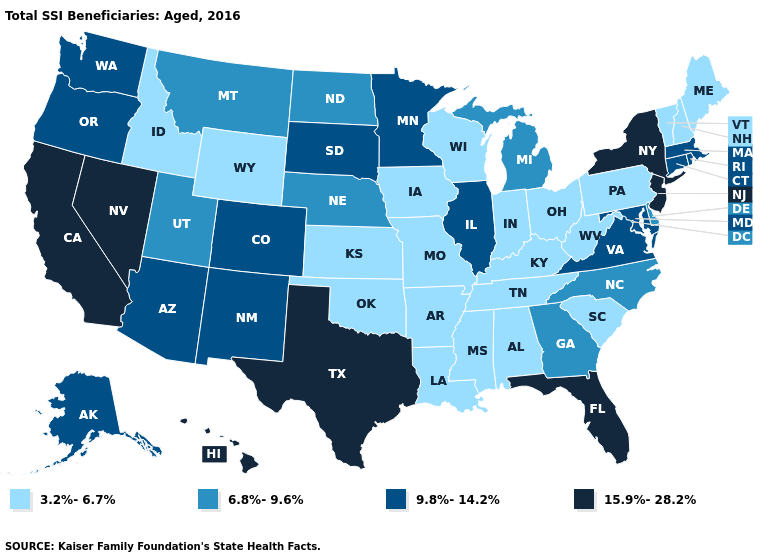What is the value of Iowa?
Be succinct. 3.2%-6.7%. What is the highest value in states that border Michigan?
Give a very brief answer. 3.2%-6.7%. Name the states that have a value in the range 9.8%-14.2%?
Write a very short answer. Alaska, Arizona, Colorado, Connecticut, Illinois, Maryland, Massachusetts, Minnesota, New Mexico, Oregon, Rhode Island, South Dakota, Virginia, Washington. What is the value of Oregon?
Write a very short answer. 9.8%-14.2%. Which states have the lowest value in the West?
Short answer required. Idaho, Wyoming. Name the states that have a value in the range 6.8%-9.6%?
Answer briefly. Delaware, Georgia, Michigan, Montana, Nebraska, North Carolina, North Dakota, Utah. Does Maryland have a higher value than Arizona?
Give a very brief answer. No. What is the value of Michigan?
Keep it brief. 6.8%-9.6%. Does Mississippi have the highest value in the South?
Give a very brief answer. No. Among the states that border Nebraska , does South Dakota have the highest value?
Short answer required. Yes. Name the states that have a value in the range 9.8%-14.2%?
Be succinct. Alaska, Arizona, Colorado, Connecticut, Illinois, Maryland, Massachusetts, Minnesota, New Mexico, Oregon, Rhode Island, South Dakota, Virginia, Washington. Does New York have the highest value in the USA?
Give a very brief answer. Yes. What is the highest value in the USA?
Give a very brief answer. 15.9%-28.2%. Does New Jersey have the lowest value in the Northeast?
Answer briefly. No. 